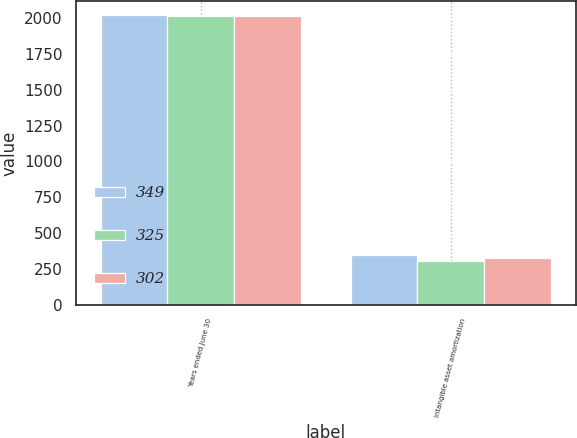Convert chart. <chart><loc_0><loc_0><loc_500><loc_500><stacked_bar_chart><ecel><fcel>Years ended June 30<fcel>Intangible asset amortization<nl><fcel>349<fcel>2019<fcel>349<nl><fcel>325<fcel>2018<fcel>302<nl><fcel>302<fcel>2017<fcel>325<nl></chart> 